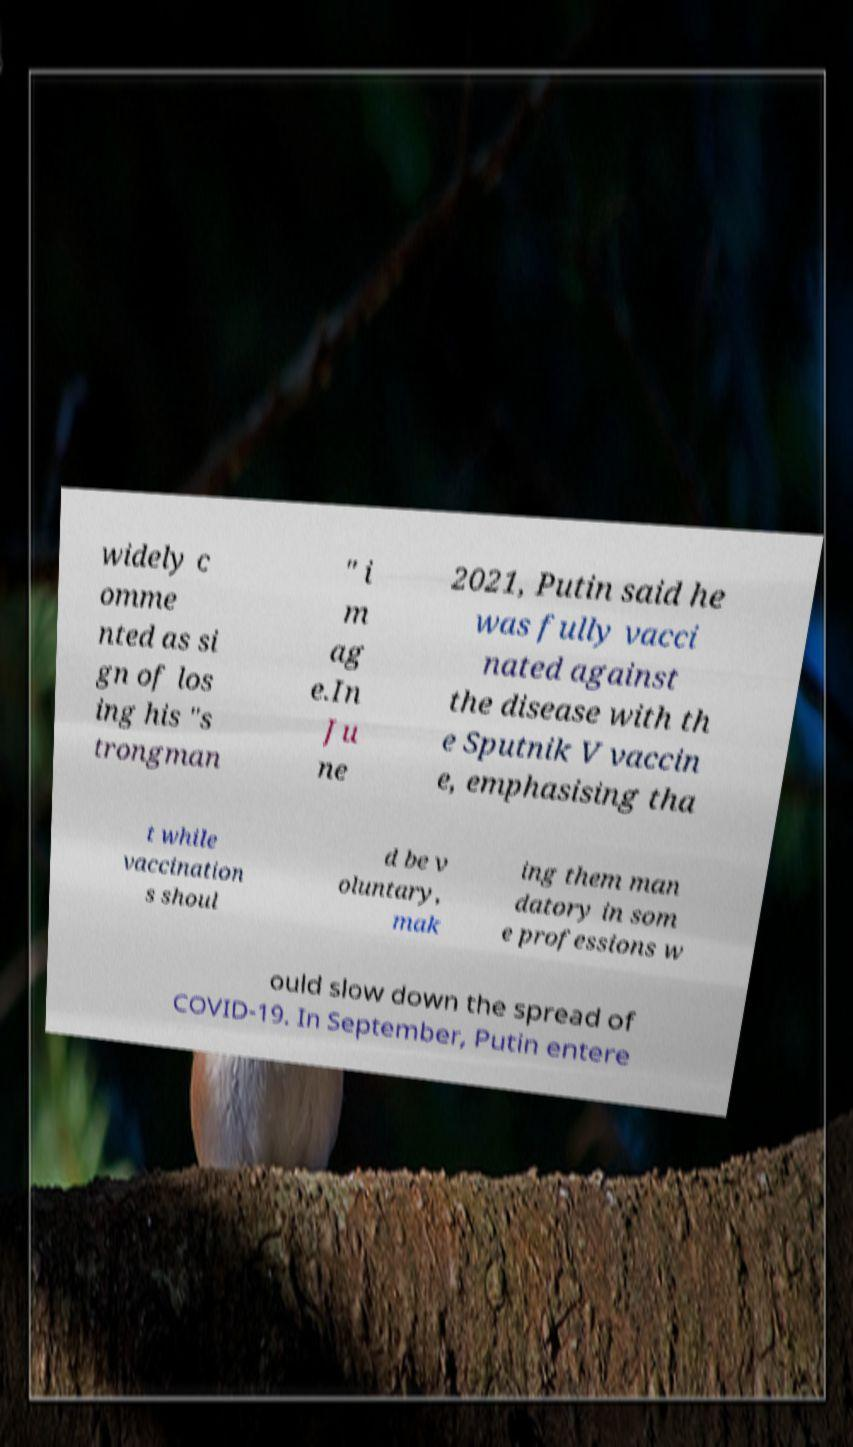Please read and relay the text visible in this image. What does it say? widely c omme nted as si gn of los ing his "s trongman " i m ag e.In Ju ne 2021, Putin said he was fully vacci nated against the disease with th e Sputnik V vaccin e, emphasising tha t while vaccination s shoul d be v oluntary, mak ing them man datory in som e professions w ould slow down the spread of COVID-19. In September, Putin entere 